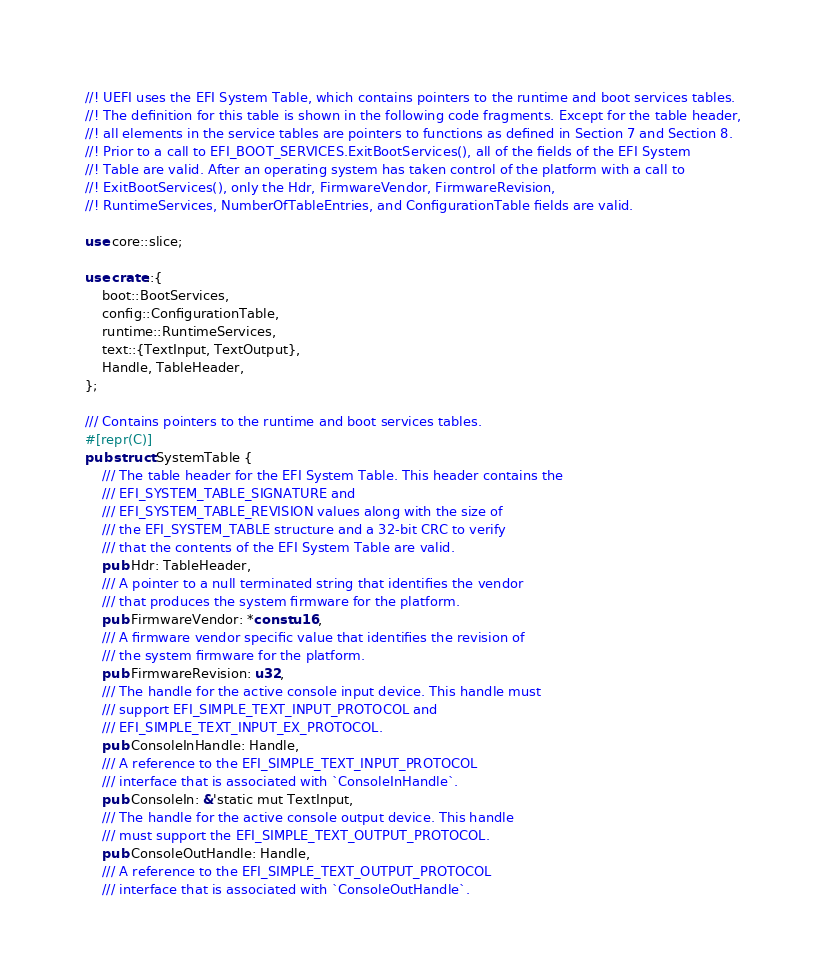<code> <loc_0><loc_0><loc_500><loc_500><_Rust_>//! UEFI uses the EFI System Table, which contains pointers to the runtime and boot services tables.
//! The definition for this table is shown in the following code fragments. Except for the table header,
//! all elements in the service tables are pointers to functions as defined in Section 7 and Section 8.
//! Prior to a call to EFI_BOOT_SERVICES.ExitBootServices(), all of the fields of the EFI System
//! Table are valid. After an operating system has taken control of the platform with a call to
//! ExitBootServices(), only the Hdr, FirmwareVendor, FirmwareRevision,
//! RuntimeServices, NumberOfTableEntries, and ConfigurationTable fields are valid.

use core::slice;

use crate::{
    boot::BootServices,
    config::ConfigurationTable,
    runtime::RuntimeServices,
    text::{TextInput, TextOutput},
    Handle, TableHeader,
};

/// Contains pointers to the runtime and boot services tables.
#[repr(C)]
pub struct SystemTable {
    /// The table header for the EFI System Table. This header contains the
    /// EFI_SYSTEM_TABLE_SIGNATURE and
    /// EFI_SYSTEM_TABLE_REVISION values along with the size of
    /// the EFI_SYSTEM_TABLE structure and a 32-bit CRC to verify
    /// that the contents of the EFI System Table are valid.
    pub Hdr: TableHeader,
    /// A pointer to a null terminated string that identifies the vendor
    /// that produces the system firmware for the platform.
    pub FirmwareVendor: *const u16,
    /// A firmware vendor specific value that identifies the revision of
    /// the system firmware for the platform.
    pub FirmwareRevision: u32,
    /// The handle for the active console input device. This handle must
    /// support EFI_SIMPLE_TEXT_INPUT_PROTOCOL and
    /// EFI_SIMPLE_TEXT_INPUT_EX_PROTOCOL.
    pub ConsoleInHandle: Handle,
    /// A reference to the EFI_SIMPLE_TEXT_INPUT_PROTOCOL
    /// interface that is associated with `ConsoleInHandle`.
    pub ConsoleIn: &'static mut TextInput,
    /// The handle for the active console output device. This handle
    /// must support the EFI_SIMPLE_TEXT_OUTPUT_PROTOCOL.
    pub ConsoleOutHandle: Handle,
    /// A reference to the EFI_SIMPLE_TEXT_OUTPUT_PROTOCOL
    /// interface that is associated with `ConsoleOutHandle`.</code> 